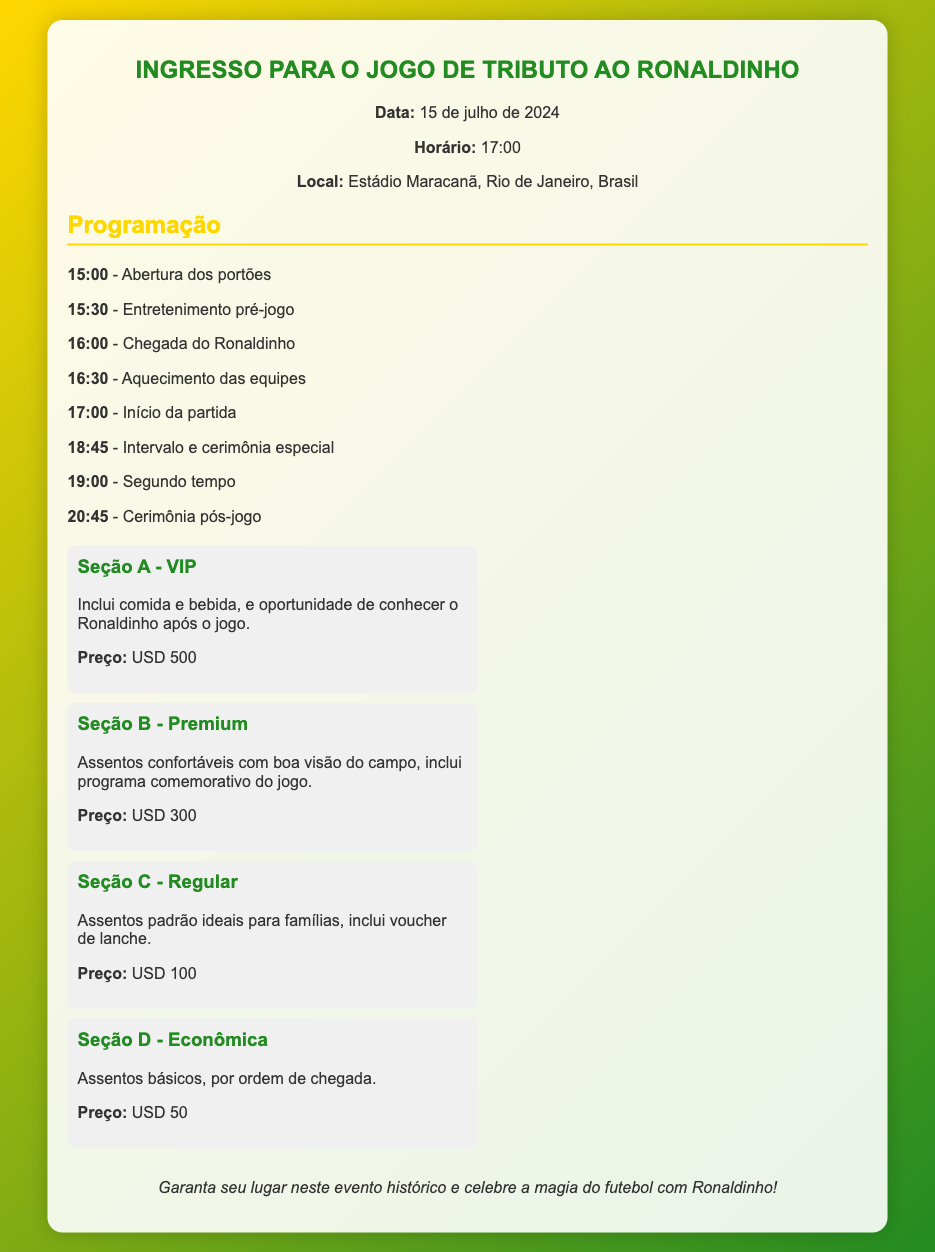qual é a data do jogo? A data do jogo é claramente mencionada no documento.
Answer: 15 de julho de 2024 qual é o horário de início da partida? O horário de início da partida é destacado na seção de programação.
Answer: 17:00 onde será realizado o evento? O local do evento está especificado na seção de informações do evento.
Answer: Estádio Maracanã, Rio de Janeiro, Brasil qual é o preço do ingresso na Seção A - VIP? O preço na Seção A - VIP é claramente indicado na parte de assentos.
Answer: USD 500 qual é a programação para 16:00? A programação específica para 16:00 é apresentada na lista de eventos.
Answer: Chegada do Ronaldinho quais são as seções de assentos disponíveis? As seções de assentos são listadas com suas respectivas descrições e preços.
Answer: A, B, C, D qual é a principal atração do evento? A principal atração do evento está implícita na descrição e título do ingresso.
Answer: Ronaldinho o que inclui a Seção B - Premium? A descrição da Seção B - Premium menciona o que está incluído.
Answer: Assentos confortáveis com boa visão do campo, inclui programa comemorativo do jogo 